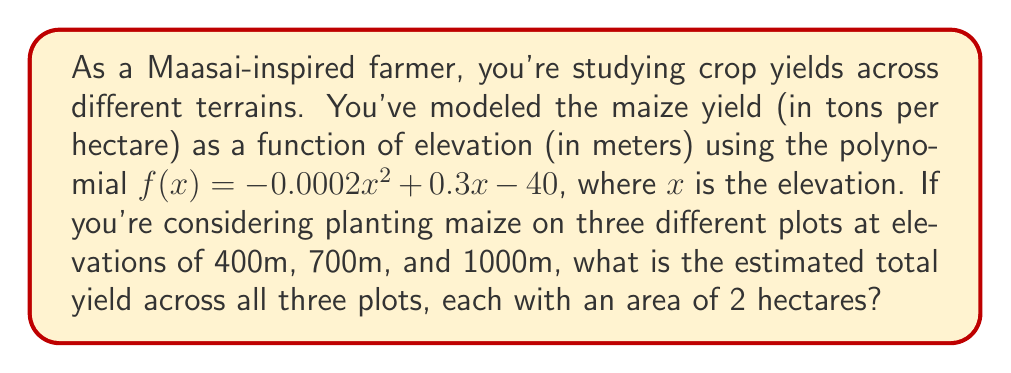Help me with this question. Let's approach this step-by-step:

1) We need to calculate the yield for each elevation using the given function:
   $f(x) = -0.0002x^2 + 0.3x - 40$

2) For 400m elevation:
   $f(400) = -0.0002(400)^2 + 0.3(400) - 40$
   $= -0.0002(160000) + 120 - 40$
   $= -32 + 120 - 40 = 48$ tons/hectare

3) For 700m elevation:
   $f(700) = -0.0002(700)^2 + 0.3(700) - 40$
   $= -0.0002(490000) + 210 - 40$
   $= -98 + 210 - 40 = 72$ tons/hectare

4) For 1000m elevation:
   $f(1000) = -0.0002(1000)^2 + 0.3(1000) - 40$
   $= -0.0002(1000000) + 300 - 40$
   $= -200 + 300 - 40 = 60$ tons/hectare

5) Now, we have the yield per hectare for each elevation. Since each plot is 2 hectares, we multiply each yield by 2:
   400m plot: $48 \times 2 = 96$ tons
   700m plot: $72 \times 2 = 144$ tons
   1000m plot: $60 \times 2 = 120$ tons

6) The total yield is the sum of these three:
   Total yield $= 96 + 144 + 120 = 360$ tons
Answer: 360 tons 